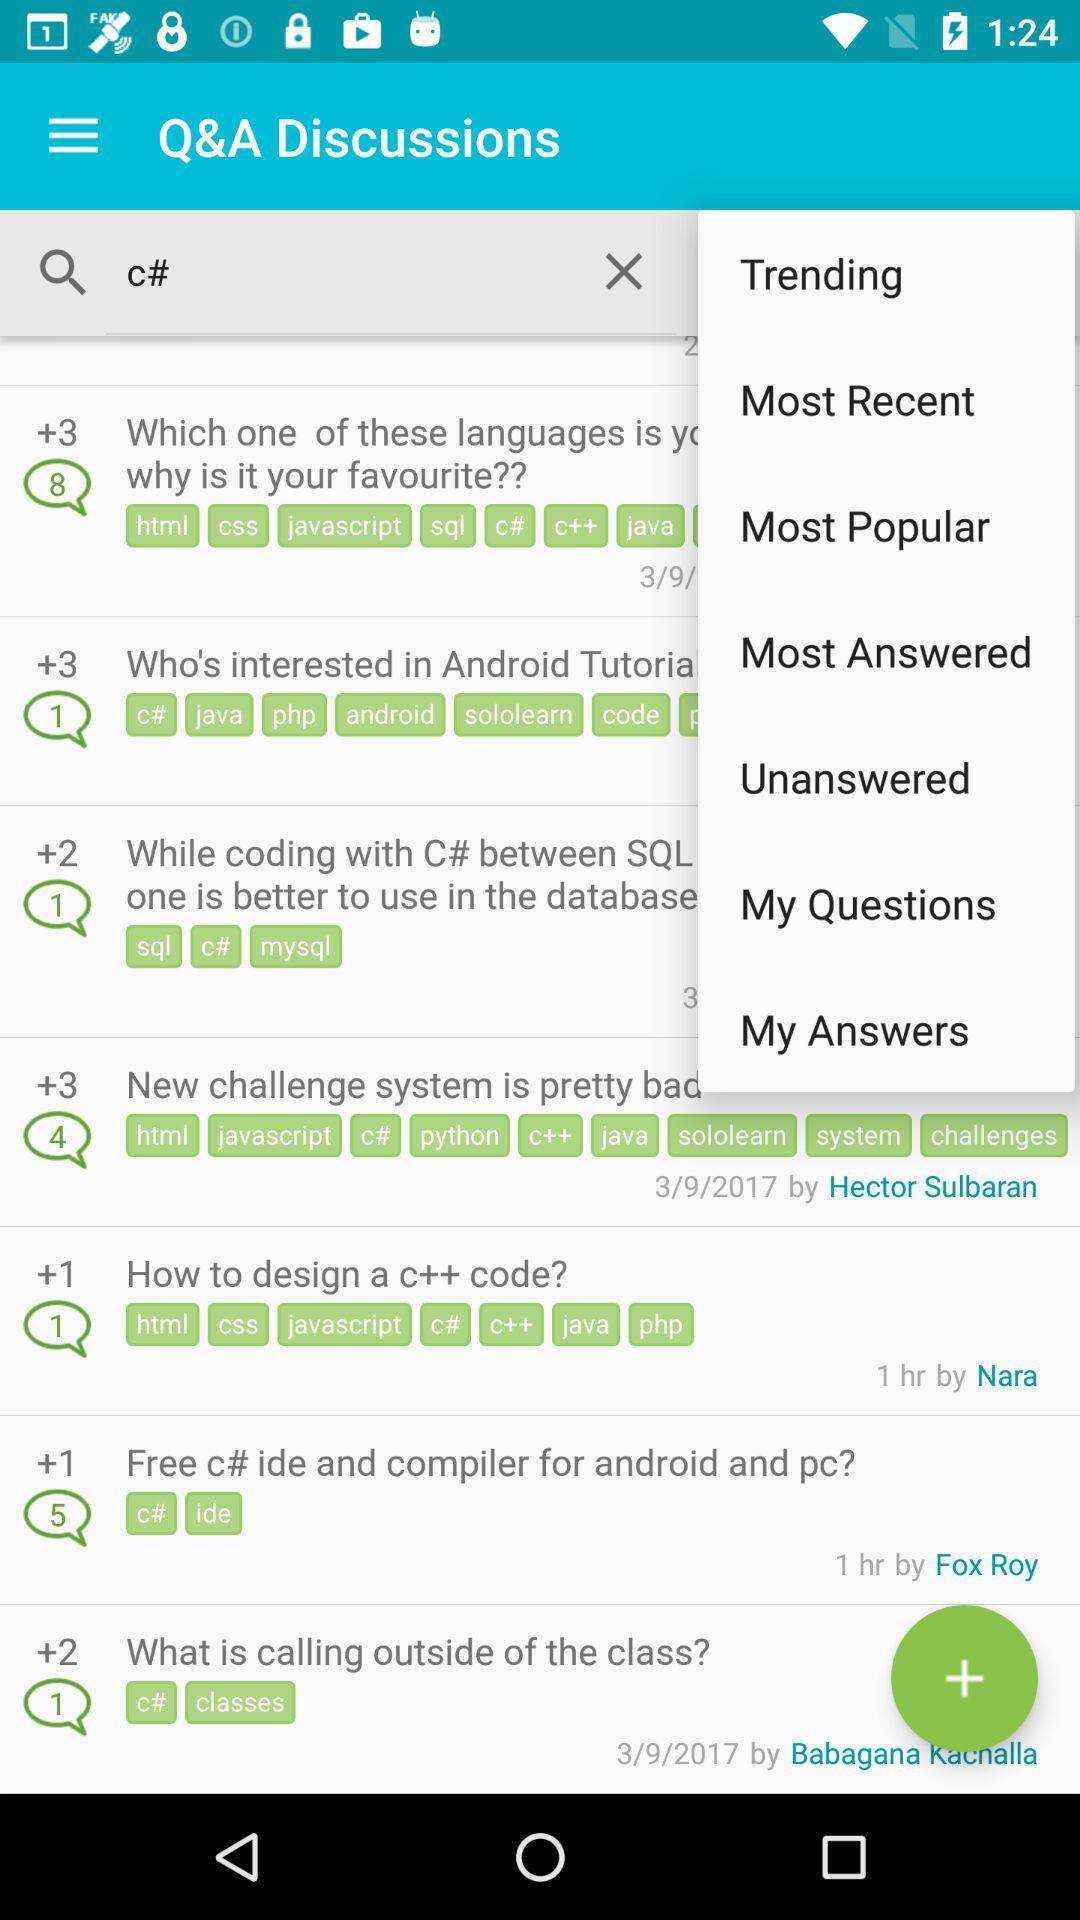On what date did Hector Sulbaran post the question? Hector Sulbaran posted the question on March 9, 2017. 